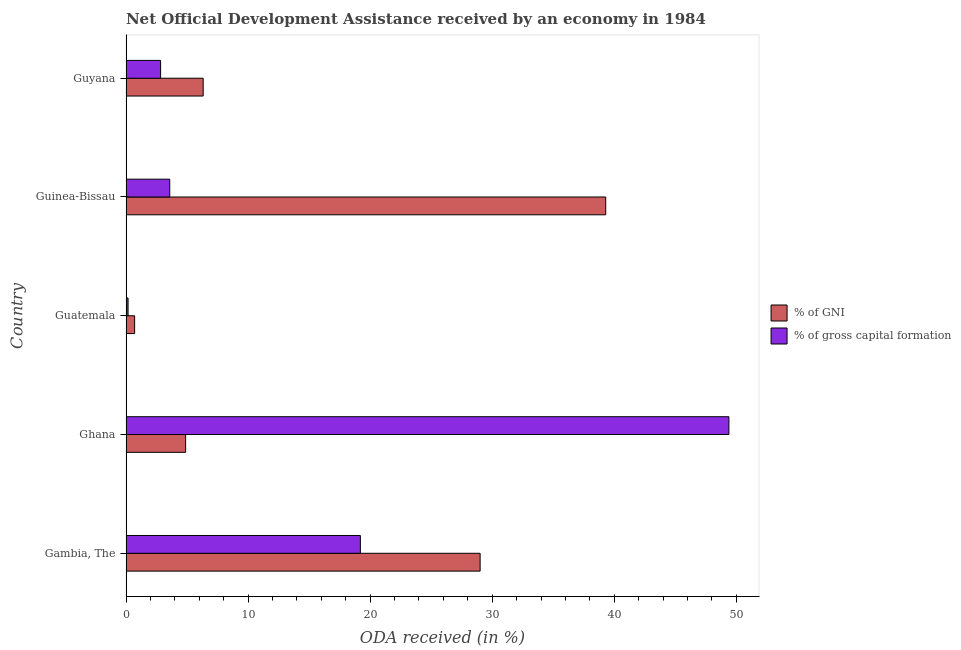Are the number of bars on each tick of the Y-axis equal?
Offer a terse response. Yes. How many bars are there on the 5th tick from the top?
Your response must be concise. 2. How many bars are there on the 2nd tick from the bottom?
Offer a terse response. 2. What is the label of the 5th group of bars from the top?
Your answer should be very brief. Gambia, The. In how many cases, is the number of bars for a given country not equal to the number of legend labels?
Your answer should be very brief. 0. What is the oda received as percentage of gni in Guatemala?
Keep it short and to the point. 0.71. Across all countries, what is the maximum oda received as percentage of gni?
Keep it short and to the point. 39.3. Across all countries, what is the minimum oda received as percentage of gni?
Offer a terse response. 0.71. In which country was the oda received as percentage of gni maximum?
Ensure brevity in your answer.  Guinea-Bissau. In which country was the oda received as percentage of gross capital formation minimum?
Offer a terse response. Guatemala. What is the total oda received as percentage of gni in the graph?
Make the answer very short. 80.22. What is the difference between the oda received as percentage of gni in Guatemala and that in Guyana?
Offer a terse response. -5.62. What is the difference between the oda received as percentage of gross capital formation in Guatemala and the oda received as percentage of gni in Ghana?
Keep it short and to the point. -4.72. What is the average oda received as percentage of gross capital formation per country?
Provide a short and direct response. 15.04. What is the difference between the oda received as percentage of gni and oda received as percentage of gross capital formation in Gambia, The?
Your answer should be compact. 9.81. What is the ratio of the oda received as percentage of gni in Guinea-Bissau to that in Guyana?
Your response must be concise. 6.22. What is the difference between the highest and the second highest oda received as percentage of gross capital formation?
Make the answer very short. 30.19. What is the difference between the highest and the lowest oda received as percentage of gni?
Keep it short and to the point. 38.6. In how many countries, is the oda received as percentage of gross capital formation greater than the average oda received as percentage of gross capital formation taken over all countries?
Offer a terse response. 2. Is the sum of the oda received as percentage of gross capital formation in Gambia, The and Guyana greater than the maximum oda received as percentage of gni across all countries?
Keep it short and to the point. No. What does the 1st bar from the top in Gambia, The represents?
Keep it short and to the point. % of gross capital formation. What does the 2nd bar from the bottom in Guyana represents?
Provide a succinct answer. % of gross capital formation. Are all the bars in the graph horizontal?
Offer a terse response. Yes. How many countries are there in the graph?
Offer a terse response. 5. What is the difference between two consecutive major ticks on the X-axis?
Provide a short and direct response. 10. Are the values on the major ticks of X-axis written in scientific E-notation?
Your answer should be compact. No. Does the graph contain grids?
Your response must be concise. No. How are the legend labels stacked?
Your answer should be compact. Vertical. What is the title of the graph?
Keep it short and to the point. Net Official Development Assistance received by an economy in 1984. What is the label or title of the X-axis?
Offer a very short reply. ODA received (in %). What is the ODA received (in %) in % of GNI in Gambia, The?
Make the answer very short. 29.01. What is the ODA received (in %) of % of gross capital formation in Gambia, The?
Make the answer very short. 19.2. What is the ODA received (in %) in % of GNI in Ghana?
Make the answer very short. 4.88. What is the ODA received (in %) in % of gross capital formation in Ghana?
Offer a terse response. 49.39. What is the ODA received (in %) of % of GNI in Guatemala?
Your answer should be very brief. 0.71. What is the ODA received (in %) of % of gross capital formation in Guatemala?
Make the answer very short. 0.17. What is the ODA received (in %) in % of GNI in Guinea-Bissau?
Provide a short and direct response. 39.3. What is the ODA received (in %) in % of gross capital formation in Guinea-Bissau?
Your response must be concise. 3.58. What is the ODA received (in %) in % of GNI in Guyana?
Your response must be concise. 6.32. What is the ODA received (in %) of % of gross capital formation in Guyana?
Your answer should be compact. 2.83. Across all countries, what is the maximum ODA received (in %) in % of GNI?
Provide a succinct answer. 39.3. Across all countries, what is the maximum ODA received (in %) in % of gross capital formation?
Your answer should be very brief. 49.39. Across all countries, what is the minimum ODA received (in %) of % of GNI?
Offer a terse response. 0.71. Across all countries, what is the minimum ODA received (in %) of % of gross capital formation?
Offer a terse response. 0.17. What is the total ODA received (in %) in % of GNI in the graph?
Keep it short and to the point. 80.22. What is the total ODA received (in %) in % of gross capital formation in the graph?
Give a very brief answer. 75.18. What is the difference between the ODA received (in %) in % of GNI in Gambia, The and that in Ghana?
Provide a succinct answer. 24.13. What is the difference between the ODA received (in %) of % of gross capital formation in Gambia, The and that in Ghana?
Your response must be concise. -30.19. What is the difference between the ODA received (in %) of % of GNI in Gambia, The and that in Guatemala?
Keep it short and to the point. 28.3. What is the difference between the ODA received (in %) of % of gross capital formation in Gambia, The and that in Guatemala?
Your answer should be compact. 19.03. What is the difference between the ODA received (in %) of % of GNI in Gambia, The and that in Guinea-Bissau?
Keep it short and to the point. -10.29. What is the difference between the ODA received (in %) in % of gross capital formation in Gambia, The and that in Guinea-Bissau?
Your answer should be compact. 15.62. What is the difference between the ODA received (in %) in % of GNI in Gambia, The and that in Guyana?
Provide a short and direct response. 22.69. What is the difference between the ODA received (in %) in % of gross capital formation in Gambia, The and that in Guyana?
Offer a terse response. 16.37. What is the difference between the ODA received (in %) of % of GNI in Ghana and that in Guatemala?
Provide a succinct answer. 4.18. What is the difference between the ODA received (in %) in % of gross capital formation in Ghana and that in Guatemala?
Give a very brief answer. 49.22. What is the difference between the ODA received (in %) in % of GNI in Ghana and that in Guinea-Bissau?
Keep it short and to the point. -34.42. What is the difference between the ODA received (in %) of % of gross capital formation in Ghana and that in Guinea-Bissau?
Offer a very short reply. 45.81. What is the difference between the ODA received (in %) in % of GNI in Ghana and that in Guyana?
Keep it short and to the point. -1.44. What is the difference between the ODA received (in %) of % of gross capital formation in Ghana and that in Guyana?
Offer a very short reply. 46.56. What is the difference between the ODA received (in %) in % of GNI in Guatemala and that in Guinea-Bissau?
Ensure brevity in your answer.  -38.6. What is the difference between the ODA received (in %) of % of gross capital formation in Guatemala and that in Guinea-Bissau?
Your response must be concise. -3.41. What is the difference between the ODA received (in %) in % of GNI in Guatemala and that in Guyana?
Provide a succinct answer. -5.62. What is the difference between the ODA received (in %) in % of gross capital formation in Guatemala and that in Guyana?
Keep it short and to the point. -2.67. What is the difference between the ODA received (in %) of % of GNI in Guinea-Bissau and that in Guyana?
Make the answer very short. 32.98. What is the difference between the ODA received (in %) in % of gross capital formation in Guinea-Bissau and that in Guyana?
Offer a terse response. 0.75. What is the difference between the ODA received (in %) of % of GNI in Gambia, The and the ODA received (in %) of % of gross capital formation in Ghana?
Offer a terse response. -20.38. What is the difference between the ODA received (in %) in % of GNI in Gambia, The and the ODA received (in %) in % of gross capital formation in Guatemala?
Offer a terse response. 28.84. What is the difference between the ODA received (in %) of % of GNI in Gambia, The and the ODA received (in %) of % of gross capital formation in Guinea-Bissau?
Your answer should be compact. 25.43. What is the difference between the ODA received (in %) of % of GNI in Gambia, The and the ODA received (in %) of % of gross capital formation in Guyana?
Your response must be concise. 26.18. What is the difference between the ODA received (in %) in % of GNI in Ghana and the ODA received (in %) in % of gross capital formation in Guatemala?
Offer a very short reply. 4.71. What is the difference between the ODA received (in %) of % of GNI in Ghana and the ODA received (in %) of % of gross capital formation in Guinea-Bissau?
Ensure brevity in your answer.  1.3. What is the difference between the ODA received (in %) of % of GNI in Ghana and the ODA received (in %) of % of gross capital formation in Guyana?
Provide a succinct answer. 2.05. What is the difference between the ODA received (in %) of % of GNI in Guatemala and the ODA received (in %) of % of gross capital formation in Guinea-Bissau?
Ensure brevity in your answer.  -2.88. What is the difference between the ODA received (in %) in % of GNI in Guatemala and the ODA received (in %) in % of gross capital formation in Guyana?
Offer a terse response. -2.13. What is the difference between the ODA received (in %) in % of GNI in Guinea-Bissau and the ODA received (in %) in % of gross capital formation in Guyana?
Provide a succinct answer. 36.47. What is the average ODA received (in %) of % of GNI per country?
Keep it short and to the point. 16.04. What is the average ODA received (in %) in % of gross capital formation per country?
Provide a succinct answer. 15.04. What is the difference between the ODA received (in %) in % of GNI and ODA received (in %) in % of gross capital formation in Gambia, The?
Ensure brevity in your answer.  9.81. What is the difference between the ODA received (in %) in % of GNI and ODA received (in %) in % of gross capital formation in Ghana?
Make the answer very short. -44.51. What is the difference between the ODA received (in %) of % of GNI and ODA received (in %) of % of gross capital formation in Guatemala?
Ensure brevity in your answer.  0.54. What is the difference between the ODA received (in %) of % of GNI and ODA received (in %) of % of gross capital formation in Guinea-Bissau?
Make the answer very short. 35.72. What is the difference between the ODA received (in %) of % of GNI and ODA received (in %) of % of gross capital formation in Guyana?
Your answer should be compact. 3.49. What is the ratio of the ODA received (in %) in % of GNI in Gambia, The to that in Ghana?
Ensure brevity in your answer.  5.94. What is the ratio of the ODA received (in %) of % of gross capital formation in Gambia, The to that in Ghana?
Provide a succinct answer. 0.39. What is the ratio of the ODA received (in %) in % of GNI in Gambia, The to that in Guatemala?
Your answer should be very brief. 41.14. What is the ratio of the ODA received (in %) in % of gross capital formation in Gambia, The to that in Guatemala?
Make the answer very short. 114.26. What is the ratio of the ODA received (in %) in % of GNI in Gambia, The to that in Guinea-Bissau?
Provide a succinct answer. 0.74. What is the ratio of the ODA received (in %) in % of gross capital formation in Gambia, The to that in Guinea-Bissau?
Ensure brevity in your answer.  5.36. What is the ratio of the ODA received (in %) of % of GNI in Gambia, The to that in Guyana?
Provide a short and direct response. 4.59. What is the ratio of the ODA received (in %) of % of gross capital formation in Gambia, The to that in Guyana?
Your response must be concise. 6.78. What is the ratio of the ODA received (in %) of % of GNI in Ghana to that in Guatemala?
Your answer should be compact. 6.92. What is the ratio of the ODA received (in %) in % of gross capital formation in Ghana to that in Guatemala?
Give a very brief answer. 293.93. What is the ratio of the ODA received (in %) of % of GNI in Ghana to that in Guinea-Bissau?
Keep it short and to the point. 0.12. What is the ratio of the ODA received (in %) in % of gross capital formation in Ghana to that in Guinea-Bissau?
Give a very brief answer. 13.78. What is the ratio of the ODA received (in %) of % of GNI in Ghana to that in Guyana?
Provide a succinct answer. 0.77. What is the ratio of the ODA received (in %) of % of gross capital formation in Ghana to that in Guyana?
Keep it short and to the point. 17.43. What is the ratio of the ODA received (in %) of % of GNI in Guatemala to that in Guinea-Bissau?
Give a very brief answer. 0.02. What is the ratio of the ODA received (in %) in % of gross capital formation in Guatemala to that in Guinea-Bissau?
Provide a succinct answer. 0.05. What is the ratio of the ODA received (in %) of % of GNI in Guatemala to that in Guyana?
Provide a short and direct response. 0.11. What is the ratio of the ODA received (in %) in % of gross capital formation in Guatemala to that in Guyana?
Make the answer very short. 0.06. What is the ratio of the ODA received (in %) in % of GNI in Guinea-Bissau to that in Guyana?
Offer a terse response. 6.22. What is the ratio of the ODA received (in %) in % of gross capital formation in Guinea-Bissau to that in Guyana?
Make the answer very short. 1.26. What is the difference between the highest and the second highest ODA received (in %) of % of GNI?
Your answer should be very brief. 10.29. What is the difference between the highest and the second highest ODA received (in %) in % of gross capital formation?
Provide a short and direct response. 30.19. What is the difference between the highest and the lowest ODA received (in %) in % of GNI?
Your response must be concise. 38.6. What is the difference between the highest and the lowest ODA received (in %) in % of gross capital formation?
Provide a short and direct response. 49.22. 